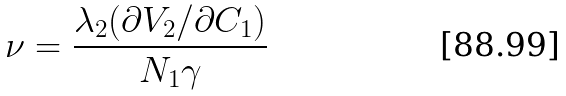Convert formula to latex. <formula><loc_0><loc_0><loc_500><loc_500>\nu = \frac { \lambda _ { 2 } ( \partial V _ { 2 } / \partial C _ { 1 } ) } { N _ { 1 } \gamma }</formula> 